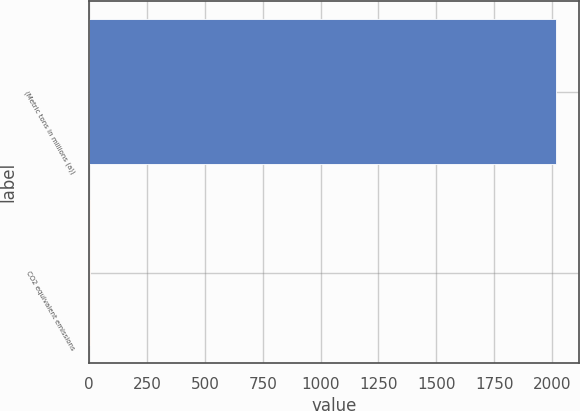<chart> <loc_0><loc_0><loc_500><loc_500><bar_chart><fcel>(Metric tons in millions (a))<fcel>CO2 equivalent emissions<nl><fcel>2017<fcel>3<nl></chart> 